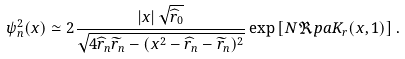<formula> <loc_0><loc_0><loc_500><loc_500>\psi _ { n } ^ { 2 } ( x ) & \simeq 2 \frac { \left | x \right | \sqrt { \widehat { r } _ { 0 } } } { \sqrt { 4 \widehat { r } _ { n } \widetilde { r } _ { n } - ( x ^ { 2 } - \widehat { r } _ { n } - \widetilde { r } _ { n } ) ^ { 2 } } } \exp \left [ N \Re p a K _ { r } ( x , 1 ) \right ] .</formula> 